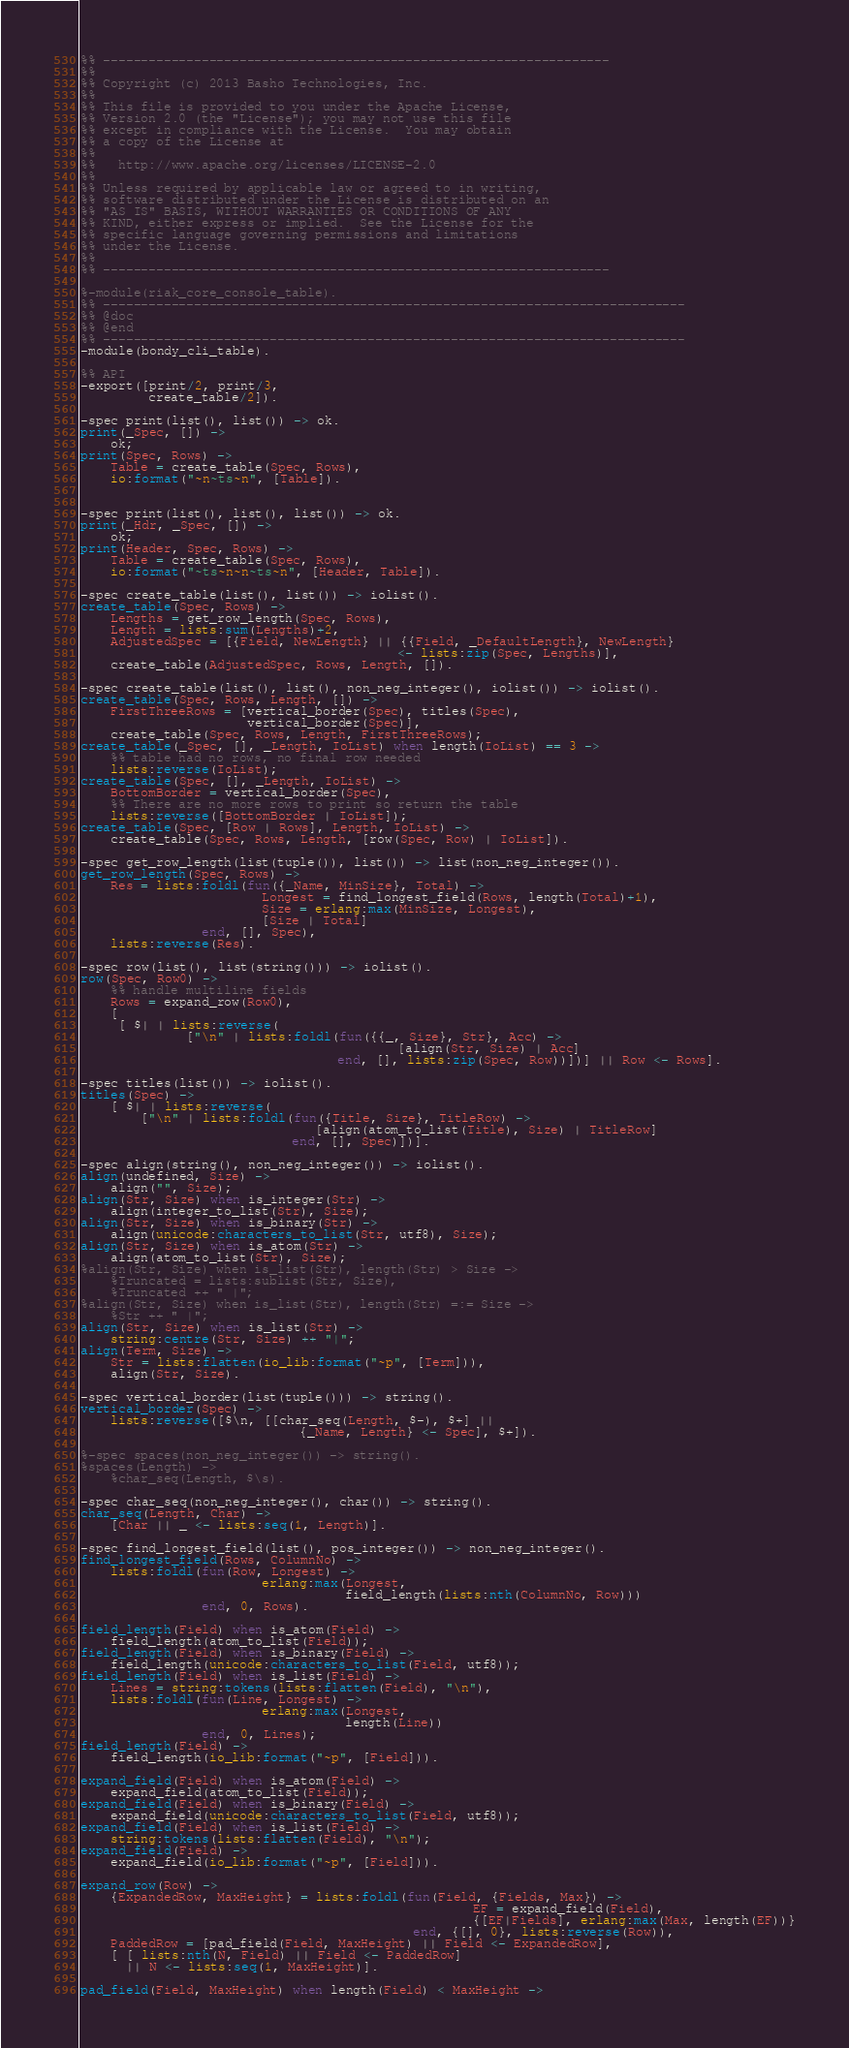Convert code to text. <code><loc_0><loc_0><loc_500><loc_500><_Erlang_>%% -------------------------------------------------------------------
%%
%% Copyright (c) 2013 Basho Technologies, Inc.
%%
%% This file is provided to you under the Apache License,
%% Version 2.0 (the "License"); you may not use this file
%% except in compliance with the License.  You may obtain
%% a copy of the License at
%%
%%   http://www.apache.org/licenses/LICENSE-2.0
%%
%% Unless required by applicable law or agreed to in writing,
%% software distributed under the License is distributed on an
%% "AS IS" BASIS, WITHOUT WARRANTIES OR CONDITIONS OF ANY
%% KIND, either express or implied.  See the License for the
%% specific language governing permissions and limitations
%% under the License.
%%
%% -------------------------------------------------------------------

%-module(riak_core_console_table).
%% -----------------------------------------------------------------------------
%% @doc
%% @end
%% -----------------------------------------------------------------------------
-module(bondy_cli_table).

%% API
-export([print/2, print/3,
         create_table/2]).

-spec print(list(), list()) -> ok.
print(_Spec, []) ->
    ok;
print(Spec, Rows) ->
    Table = create_table(Spec, Rows),
    io:format("~n~ts~n", [Table]).


-spec print(list(), list(), list()) -> ok.
print(_Hdr, _Spec, []) ->
    ok;
print(Header, Spec, Rows) ->
    Table = create_table(Spec, Rows),
    io:format("~ts~n~n~ts~n", [Header, Table]).

-spec create_table(list(), list()) -> iolist().
create_table(Spec, Rows) ->
    Lengths = get_row_length(Spec, Rows),
    Length = lists:sum(Lengths)+2,
    AdjustedSpec = [{Field, NewLength} || {{Field, _DefaultLength}, NewLength}
                                          <- lists:zip(Spec, Lengths)],
    create_table(AdjustedSpec, Rows, Length, []).

-spec create_table(list(), list(), non_neg_integer(), iolist()) -> iolist().
create_table(Spec, Rows, Length, []) ->
    FirstThreeRows = [vertical_border(Spec), titles(Spec),
                      vertical_border(Spec)],
    create_table(Spec, Rows, Length, FirstThreeRows);
create_table(_Spec, [], _Length, IoList) when length(IoList) == 3 ->
    %% table had no rows, no final row needed
    lists:reverse(IoList);
create_table(Spec, [], _Length, IoList) ->
    BottomBorder = vertical_border(Spec),
    %% There are no more rows to print so return the table
    lists:reverse([BottomBorder | IoList]);
create_table(Spec, [Row | Rows], Length, IoList) ->
    create_table(Spec, Rows, Length, [row(Spec, Row) | IoList]).

-spec get_row_length(list(tuple()), list()) -> list(non_neg_integer()).
get_row_length(Spec, Rows) ->
    Res = lists:foldl(fun({_Name, MinSize}, Total) ->
                        Longest = find_longest_field(Rows, length(Total)+1),
                        Size = erlang:max(MinSize, Longest),
                        [Size | Total]
                end, [], Spec),
    lists:reverse(Res).

-spec row(list(), list(string())) -> iolist().
row(Spec, Row0) ->
    %% handle multiline fields
    Rows = expand_row(Row0),
    [
     [ $| | lists:reverse(
              ["\n" | lists:foldl(fun({{_, Size}, Str}, Acc) ->
                                          [align(Str, Size) | Acc]
                                  end, [], lists:zip(Spec, Row))])] || Row <- Rows].

-spec titles(list()) -> iolist().
titles(Spec) ->
    [ $| | lists:reverse(
        ["\n" | lists:foldl(fun({Title, Size}, TitleRow) ->
                               [align(atom_to_list(Title), Size) | TitleRow]
                            end, [], Spec)])].

-spec align(string(), non_neg_integer()) -> iolist().
align(undefined, Size) ->
    align("", Size);
align(Str, Size) when is_integer(Str) ->
    align(integer_to_list(Str), Size);
align(Str, Size) when is_binary(Str) ->
    align(unicode:characters_to_list(Str, utf8), Size);
align(Str, Size) when is_atom(Str) ->
    align(atom_to_list(Str), Size);
%align(Str, Size) when is_list(Str), length(Str) > Size ->
    %Truncated = lists:sublist(Str, Size),
    %Truncated ++ " |";
%align(Str, Size) when is_list(Str), length(Str) =:= Size ->
    %Str ++ " |";
align(Str, Size) when is_list(Str) ->
    string:centre(Str, Size) ++ "|";
align(Term, Size) ->
    Str = lists:flatten(io_lib:format("~p", [Term])),
    align(Str, Size).

-spec vertical_border(list(tuple())) -> string().
vertical_border(Spec) ->
    lists:reverse([$\n, [[char_seq(Length, $-), $+] ||
                             {_Name, Length} <- Spec], $+]).

%-spec spaces(non_neg_integer()) -> string().
%spaces(Length) ->
    %char_seq(Length, $\s).

-spec char_seq(non_neg_integer(), char()) -> string().
char_seq(Length, Char) ->
    [Char || _ <- lists:seq(1, Length)].

-spec find_longest_field(list(), pos_integer()) -> non_neg_integer().
find_longest_field(Rows, ColumnNo) ->
    lists:foldl(fun(Row, Longest) ->
                        erlang:max(Longest,
                                   field_length(lists:nth(ColumnNo, Row)))
                end, 0, Rows).

field_length(Field) when is_atom(Field) ->
    field_length(atom_to_list(Field));
field_length(Field) when is_binary(Field) ->
    field_length(unicode:characters_to_list(Field, utf8));
field_length(Field) when is_list(Field) ->
    Lines = string:tokens(lists:flatten(Field), "\n"),
    lists:foldl(fun(Line, Longest) ->
                        erlang:max(Longest,
                                   length(Line))
                end, 0, Lines);
field_length(Field) ->
    field_length(io_lib:format("~p", [Field])).

expand_field(Field) when is_atom(Field) ->
    expand_field(atom_to_list(Field));
expand_field(Field) when is_binary(Field) ->
    expand_field(unicode:characters_to_list(Field, utf8));
expand_field(Field) when is_list(Field) ->
    string:tokens(lists:flatten(Field), "\n");
expand_field(Field) ->
    expand_field(io_lib:format("~p", [Field])).

expand_row(Row) ->
    {ExpandedRow, MaxHeight} = lists:foldl(fun(Field, {Fields, Max}) ->
                                                    EF = expand_field(Field),
                                                    {[EF|Fields], erlang:max(Max, length(EF))}
                                            end, {[], 0}, lists:reverse(Row)),
    PaddedRow = [pad_field(Field, MaxHeight) || Field <- ExpandedRow],
    [ [ lists:nth(N, Field) || Field <- PaddedRow]
      || N <- lists:seq(1, MaxHeight)].

pad_field(Field, MaxHeight) when length(Field) < MaxHeight -></code> 